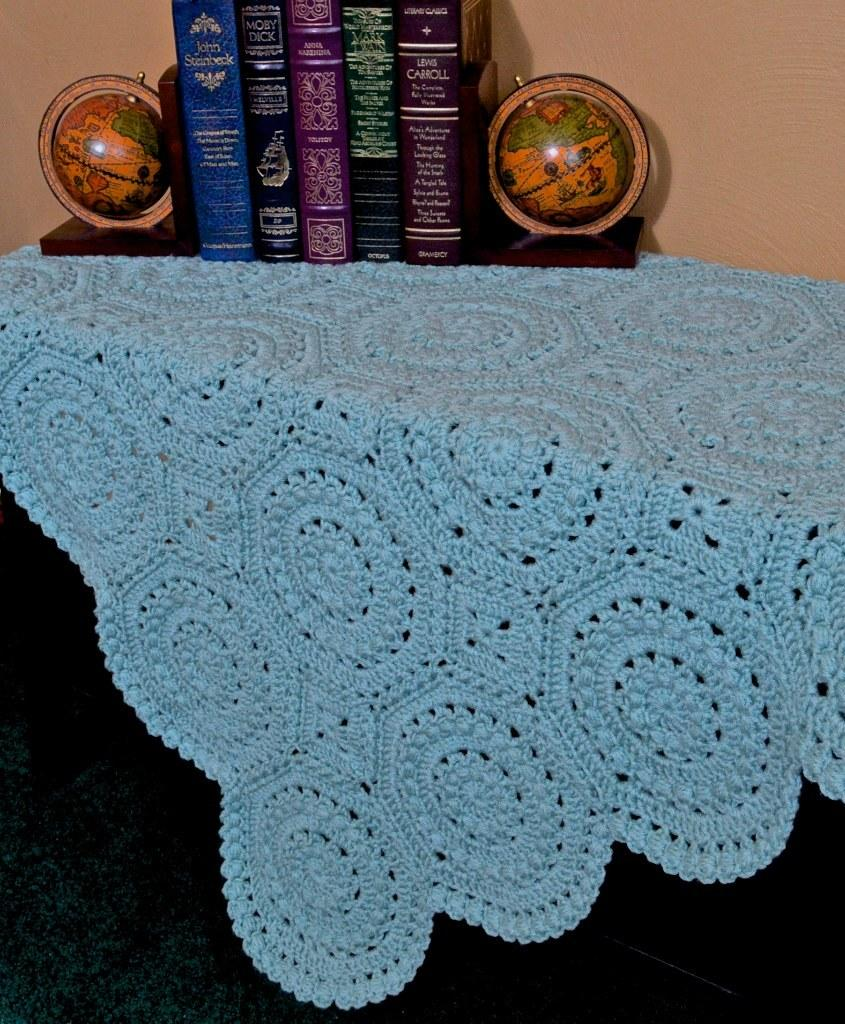<image>
Create a compact narrative representing the image presented. A John Steinbeck book sits next to several others on a small table. 